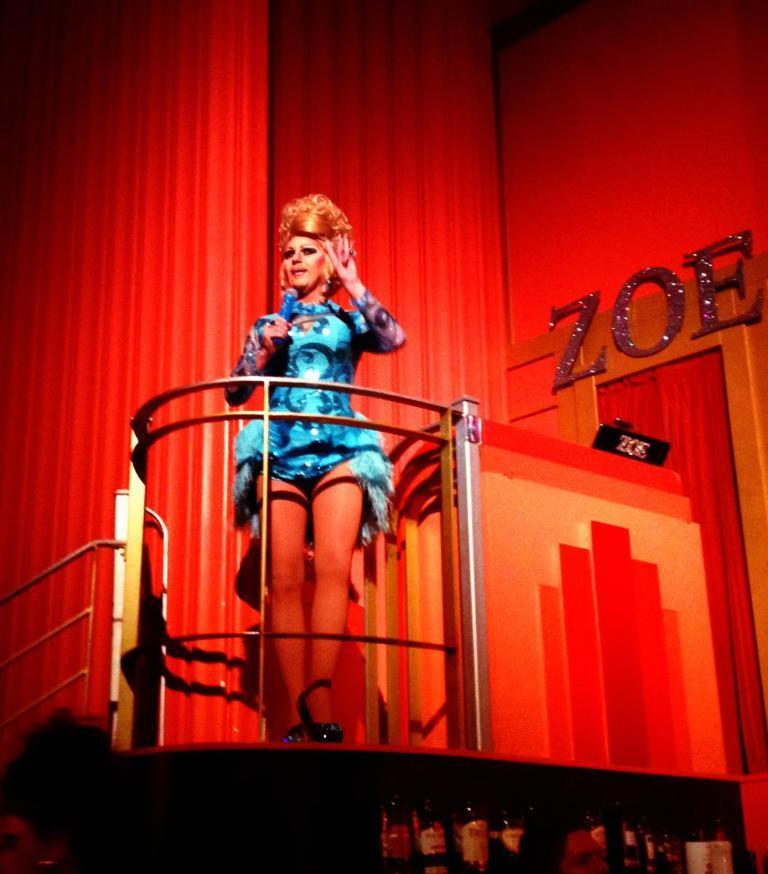Can you describe this image briefly? In the image we can see a woman standing, wearing clothes, sandals and holding a microphone in her hands. Here we can see the fence, text and the wall. 